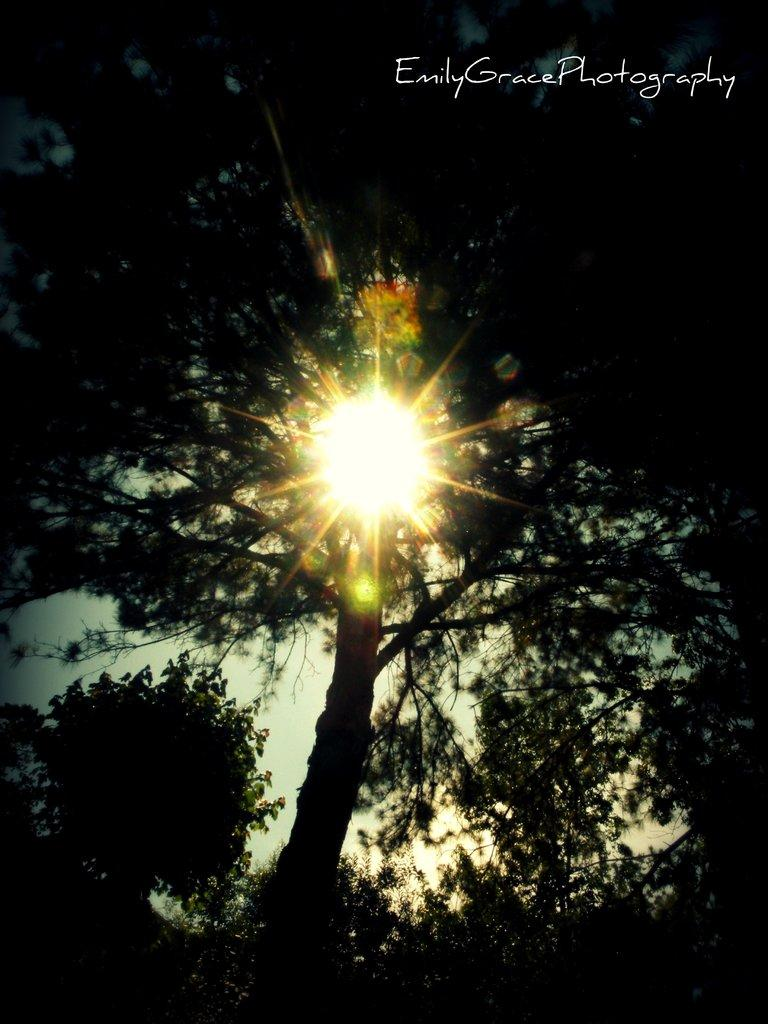What type of vegetation can be seen in the image? There are trees in the image. What is the source of light in the image? There is sunlight visible in the image. What part of the natural environment is visible in the image? The sky is visible in the background of the image. How many snakes are slithering around in the image? There are no snakes present in the image. What is the condition of the cellar in the image? There is no cellar present in the image. 